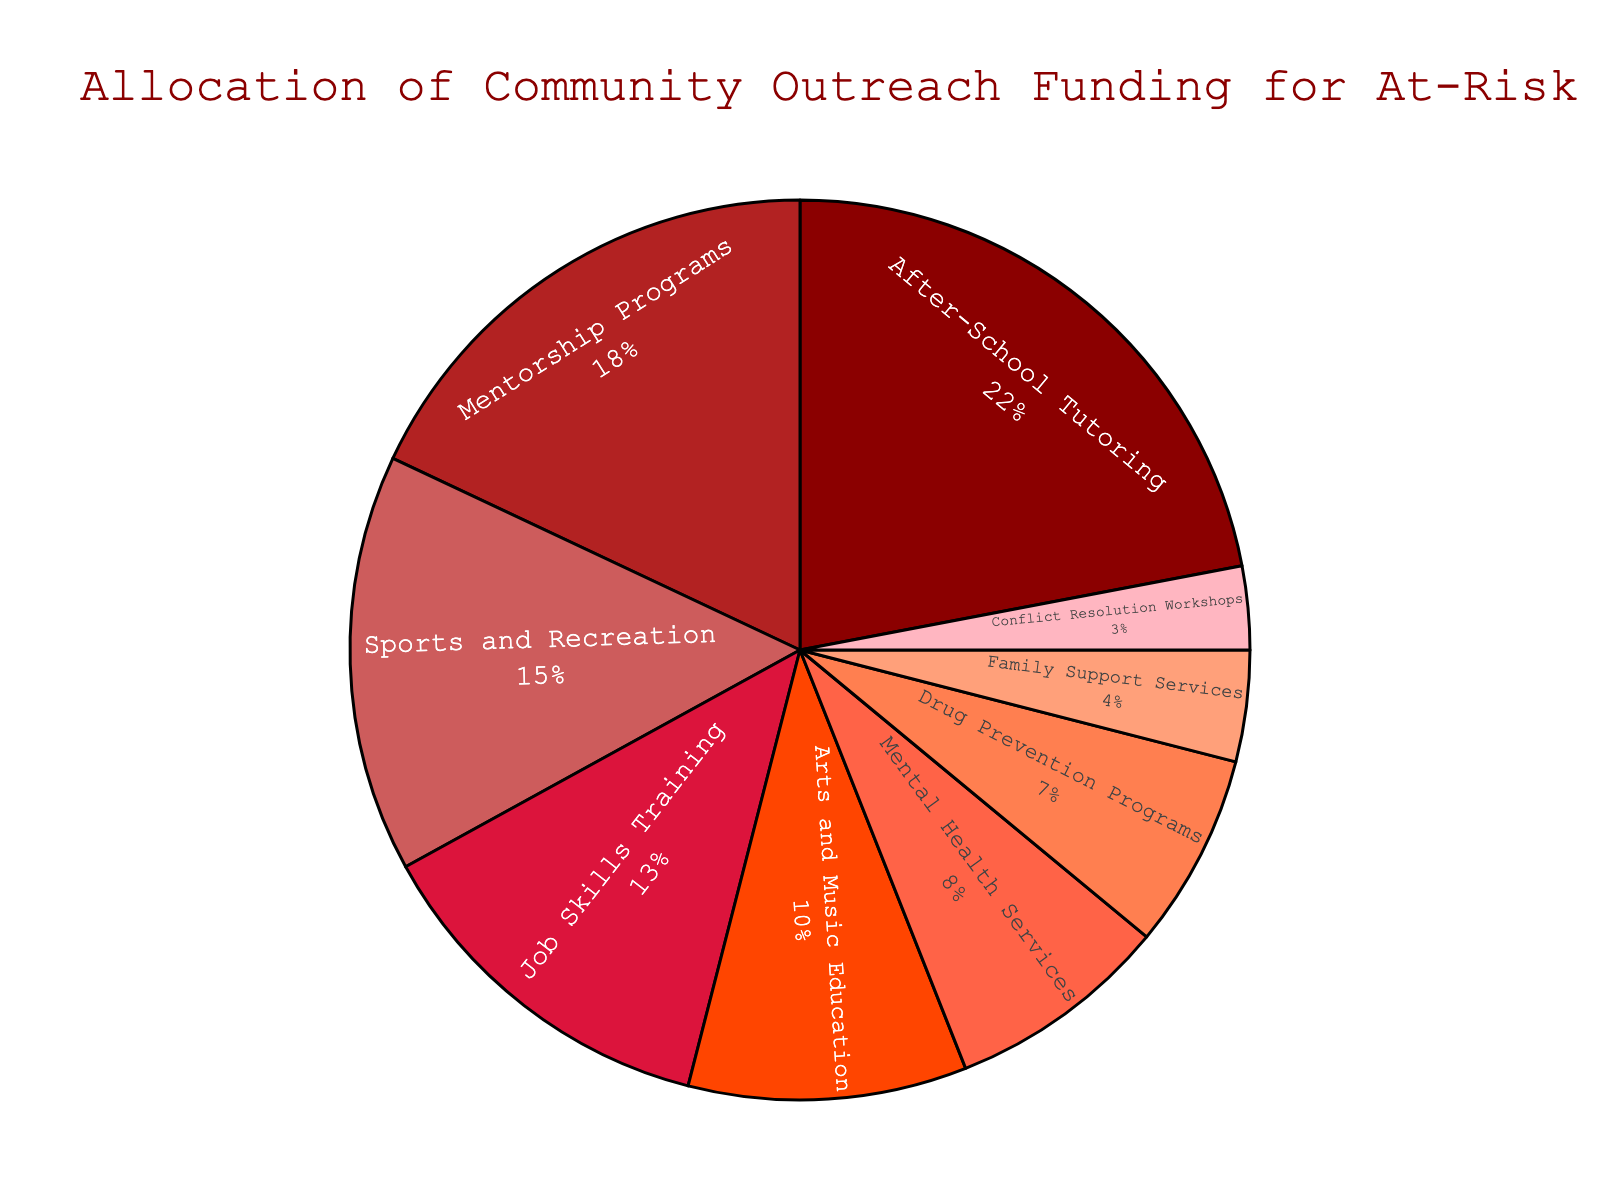Which program receives the highest percentage of funding? The figure shows each program's funding percentage. By looking at the pie chart, we can see that the After-School Tutoring program has the largest slice.
Answer: After-School Tutoring By how many percentage points does funding for Mentorship Programs differ from funding for Job Skills Training? The funding for Mentorship Programs is 18%, and for Job Skills Training it is 13%. Subtracting these gives 18 - 13 = 5 percentage points.
Answer: 5 What is the combined funding percentage for Sports and Recreation and Arts and Music Education programs? We need to add the funding percentages for the two programs. Sports and Recreation has 15% and Arts and Music Education has 10%, so 15 + 10 = 25%.
Answer: 25% Which program receives less funding: Mental Health Services or Drug Prevention Programs? The figure shows that Mental Health Services have 8% and Drug Prevention Programs have 7%. Comparing the two, Drug Prevention Programs receive less funding.
Answer: Drug Prevention Programs Are there any programs that receive an equal percentage of funding? We analyze the figure to compare the funding percentages of all programs. All the funding percentages displayed are different, hence no two programs receive an equal percentage.
Answer: No What's the difference in funding between the program receiving the most funding and the program receiving the least funding? The highest funding is for After-School Tutoring at 22%, and the least funding is for Conflict Resolution Workshops at 3%. The difference is 22 - 3 = 19%.
Answer: 19% How many programs receive more than 10% of funding? By observing the pie chart and summing the programs with more than 10% funding: After-School Tutoring (22%), Mentorship Programs (18%), Sports and Recreation (15%), and Job Skills Training (13%), making a total of 4 programs.
Answer: 4 What is the color of the section representing Family Support Services? By referring to the color scheme in the pie chart, Family Support Services is represented by a shade of light pink.
Answer: Light pink Which program receives the closest funding percentage to 20%? Observing the funding percentages, Mentorship Programs with 18% is closest to 20%.
Answer: Mentorship Programs What is the sum of the funding percentages for programs focusing on health (Mental Health Services and Drug Prevention Programs)? Adding the funding percentages of Mental Health Services (8%) and Drug Prevention Programs (7%) gives us 8 + 7 = 15%.
Answer: 15% 